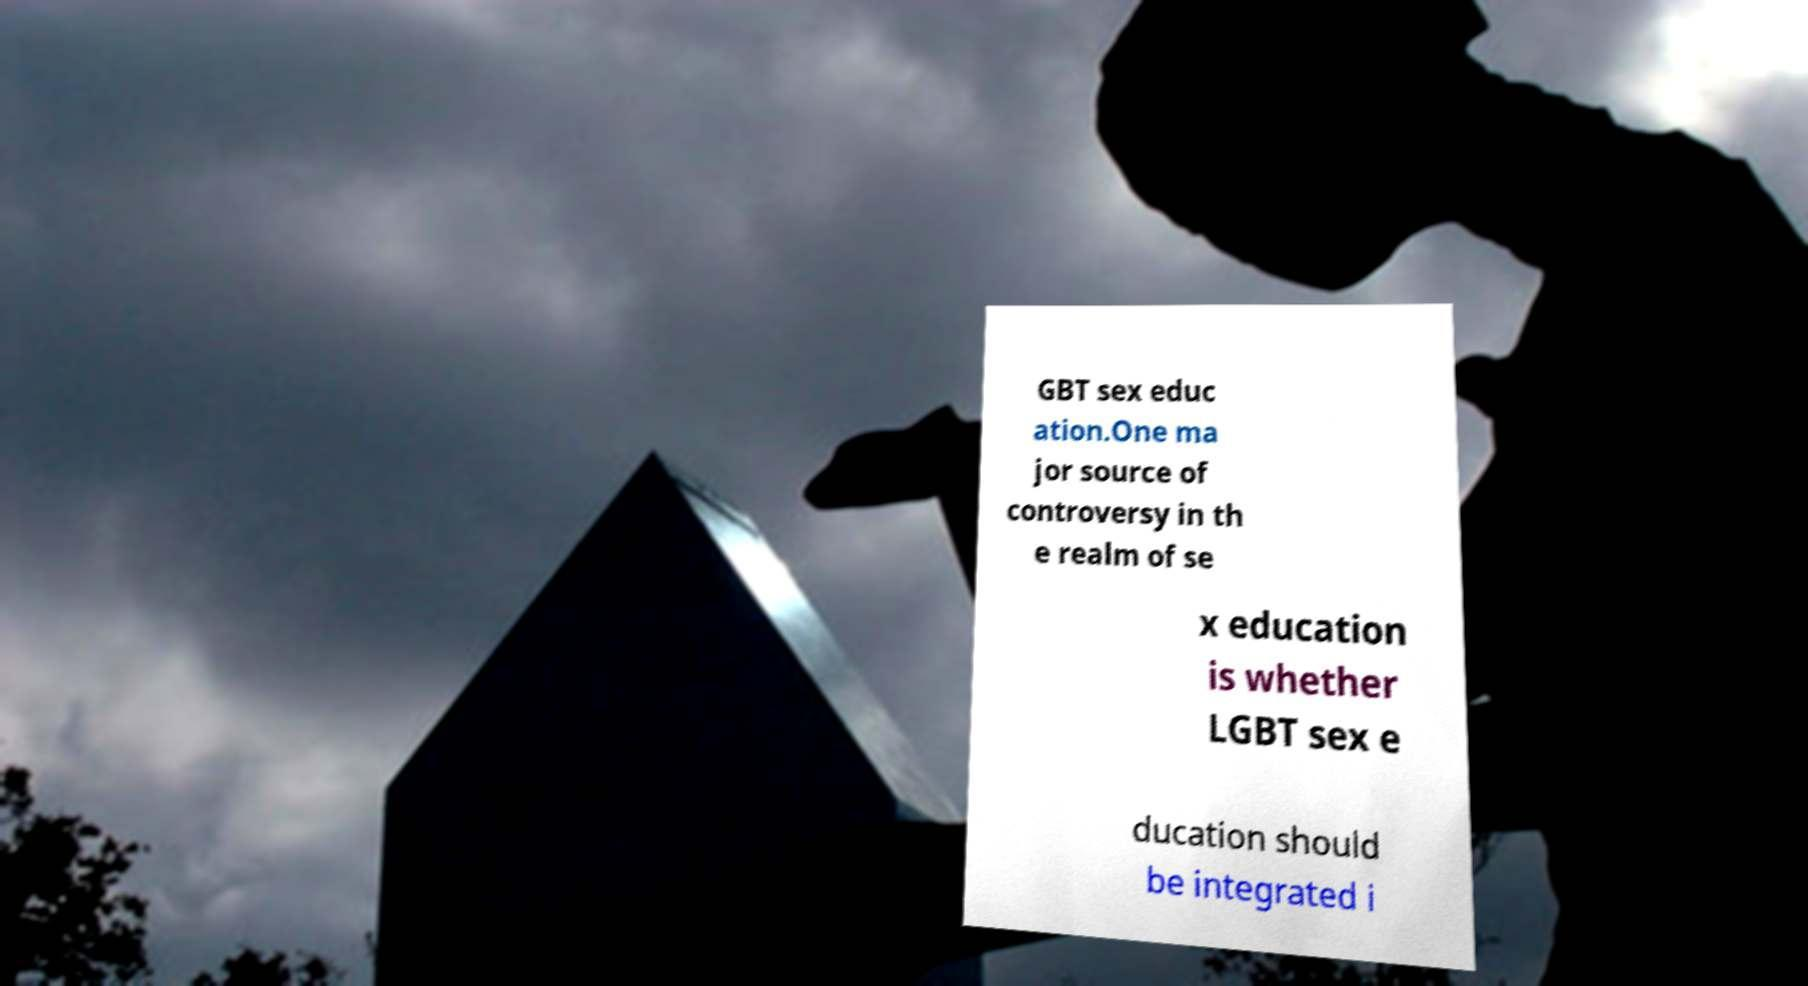There's text embedded in this image that I need extracted. Can you transcribe it verbatim? GBT sex educ ation.One ma jor source of controversy in th e realm of se x education is whether LGBT sex e ducation should be integrated i 